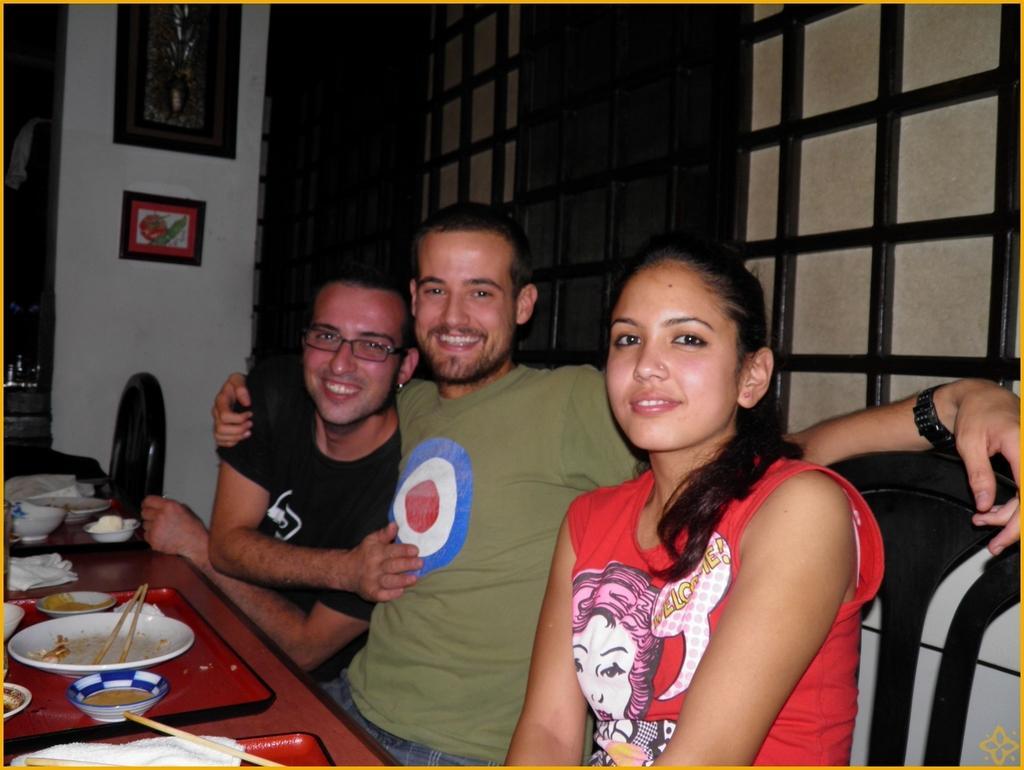How would you summarize this image in a sentence or two? In this picture we can see three people, they are smiling, in front of them we can see a platform, here we can see chairs, plate, bowls, chopsticks, tissue papers, trays and some objects and in the background we can see a wall, photo frames, windows. 